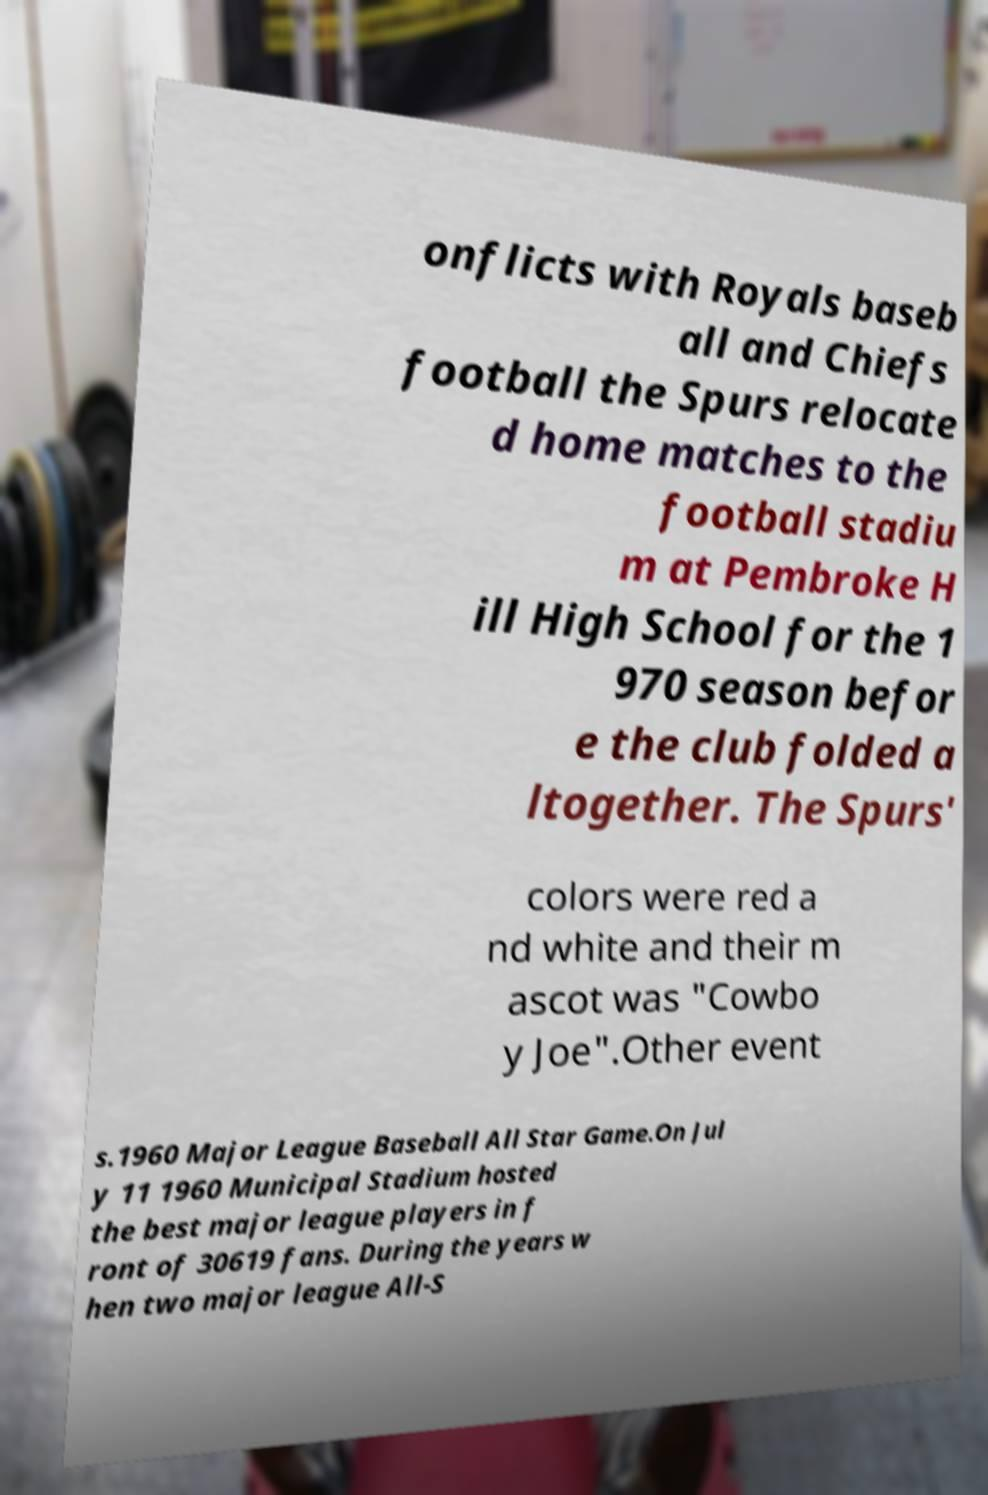There's text embedded in this image that I need extracted. Can you transcribe it verbatim? onflicts with Royals baseb all and Chiefs football the Spurs relocate d home matches to the football stadiu m at Pembroke H ill High School for the 1 970 season befor e the club folded a ltogether. The Spurs' colors were red a nd white and their m ascot was "Cowbo y Joe".Other event s.1960 Major League Baseball All Star Game.On Jul y 11 1960 Municipal Stadium hosted the best major league players in f ront of 30619 fans. During the years w hen two major league All-S 